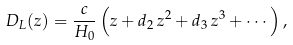Convert formula to latex. <formula><loc_0><loc_0><loc_500><loc_500>D _ { L } ( z ) = \frac { c } { H _ { 0 } } \left ( z + { d _ { 2 } } \, z ^ { 2 } + { d _ { 3 } } \, z ^ { 3 } + \cdots \right ) ,</formula> 